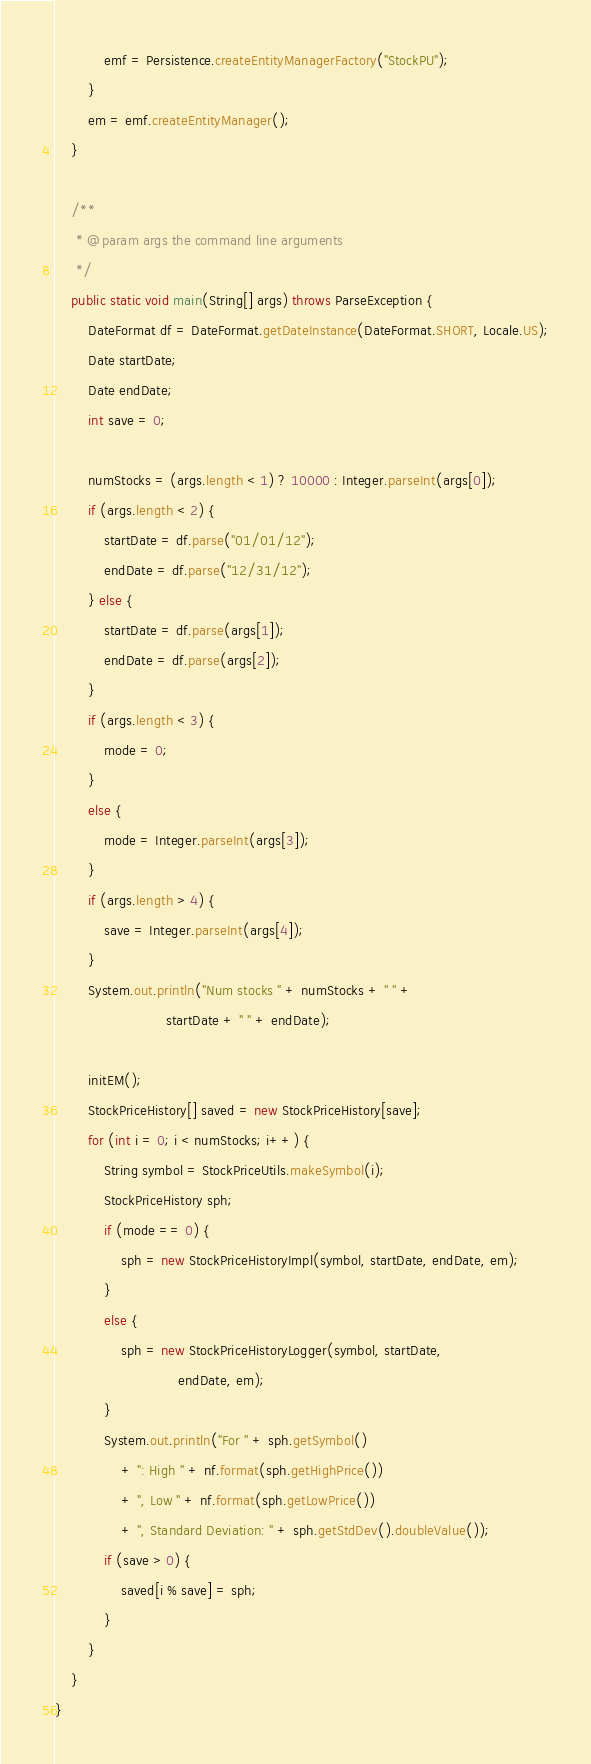Convert code to text. <code><loc_0><loc_0><loc_500><loc_500><_Java_>            emf = Persistence.createEntityManagerFactory("StockPU");
        }
        em = emf.createEntityManager();
    }

    /**
     * @param args the command line arguments
     */
    public static void main(String[] args) throws ParseException {
        DateFormat df = DateFormat.getDateInstance(DateFormat.SHORT, Locale.US);
        Date startDate;
        Date endDate;
        int save = 0;

        numStocks = (args.length < 1) ? 10000 : Integer.parseInt(args[0]);
        if (args.length < 2) {
            startDate = df.parse("01/01/12");
            endDate = df.parse("12/31/12");
        } else {
            startDate = df.parse(args[1]);
            endDate = df.parse(args[2]);
        }
        if (args.length < 3) {
            mode = 0;
        } 
        else {
            mode = Integer.parseInt(args[3]);
        }
        if (args.length > 4) {
            save = Integer.parseInt(args[4]);
        }
        System.out.println("Num stocks " + numStocks + " " +
                           startDate + " " + endDate);

        initEM();
        StockPriceHistory[] saved = new StockPriceHistory[save];
        for (int i = 0; i < numStocks; i++) {
            String symbol = StockPriceUtils.makeSymbol(i);
            StockPriceHistory sph;
            if (mode == 0) {
                sph = new StockPriceHistoryImpl(symbol, startDate, endDate, em);
            }
            else {
                sph = new StockPriceHistoryLogger(symbol, startDate,
                              endDate, em);
            }
            System.out.println("For " + sph.getSymbol()
                + ": High " + nf.format(sph.getHighPrice())
                + ", Low " + nf.format(sph.getLowPrice())
                + ", Standard Deviation: " + sph.getStdDev().doubleValue());
            if (save > 0) {
                saved[i % save] = sph;
            }
        }
    }
}
</code> 